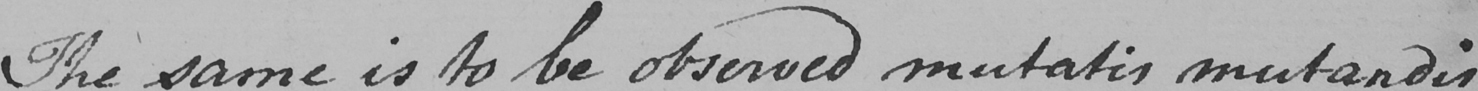What text is written in this handwritten line? The same is to be observed mutatis mutandis 